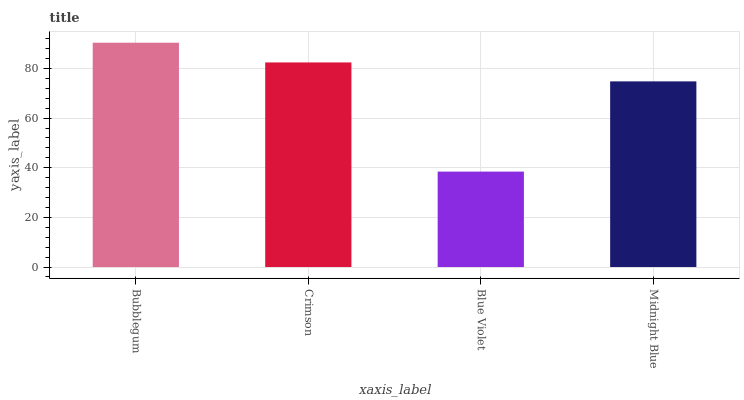Is Blue Violet the minimum?
Answer yes or no. Yes. Is Bubblegum the maximum?
Answer yes or no. Yes. Is Crimson the minimum?
Answer yes or no. No. Is Crimson the maximum?
Answer yes or no. No. Is Bubblegum greater than Crimson?
Answer yes or no. Yes. Is Crimson less than Bubblegum?
Answer yes or no. Yes. Is Crimson greater than Bubblegum?
Answer yes or no. No. Is Bubblegum less than Crimson?
Answer yes or no. No. Is Crimson the high median?
Answer yes or no. Yes. Is Midnight Blue the low median?
Answer yes or no. Yes. Is Midnight Blue the high median?
Answer yes or no. No. Is Bubblegum the low median?
Answer yes or no. No. 